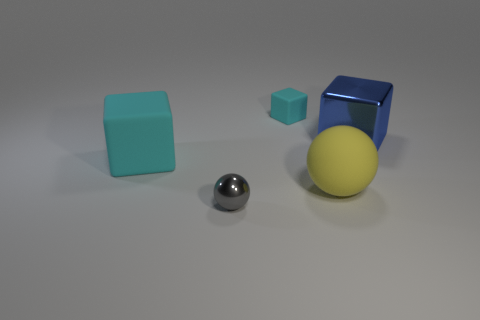What number of other things are there of the same color as the large rubber block?
Ensure brevity in your answer.  1. Do the big rubber object that is behind the yellow thing and the small matte object have the same color?
Make the answer very short. Yes. The cube that is the same color as the small rubber thing is what size?
Provide a succinct answer. Large. Is the color of the small cube the same as the large rubber block?
Give a very brief answer. Yes. There is a yellow rubber object; what shape is it?
Offer a terse response. Sphere. Is there a large thing of the same color as the tiny matte thing?
Provide a short and direct response. Yes. Is the number of blocks that are on the left side of the big blue cube greater than the number of small gray things?
Your answer should be very brief. Yes. Is the shape of the blue thing the same as the metallic thing that is to the left of the tiny cyan cube?
Your answer should be compact. No. Are there any large rubber things?
Provide a succinct answer. Yes. How many small objects are either gray balls or cyan rubber objects?
Provide a short and direct response. 2. 